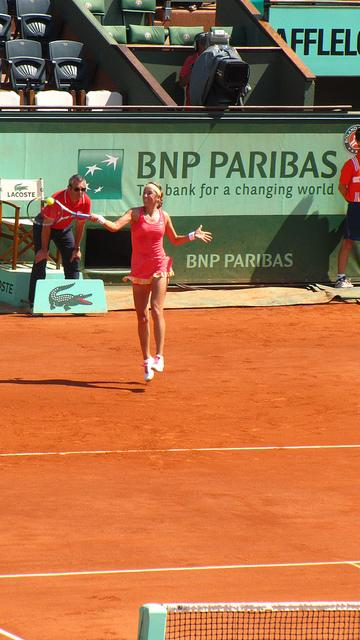What shirt brand is represented by the amphibious animal? Please explain your reasoning. polo. The brand usually has an aligator as their logo. 